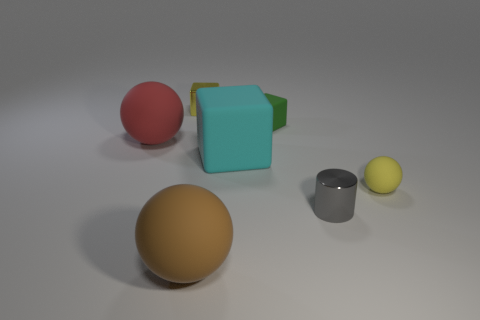There is a thing that is right of the shiny cube and behind the big cyan rubber thing; what is its material?
Offer a terse response. Rubber. What is the color of the large sphere on the right side of the red matte thing in front of the small cube that is on the right side of the small yellow cube?
Provide a succinct answer. Brown. What number of red things are small cylinders or tiny things?
Your answer should be compact. 0. What number of other objects are the same size as the gray metal cylinder?
Provide a short and direct response. 3. How many big matte spheres are there?
Ensure brevity in your answer.  2. Is there any other thing that has the same shape as the green rubber thing?
Provide a short and direct response. Yes. Do the tiny thing on the left side of the brown rubber thing and the cyan cube that is to the right of the brown rubber sphere have the same material?
Your answer should be very brief. No. What is the large red thing made of?
Make the answer very short. Rubber. What number of yellow balls have the same material as the cylinder?
Your response must be concise. 0. How many rubber objects are blue cylinders or tiny gray objects?
Ensure brevity in your answer.  0. 